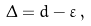<formula> <loc_0><loc_0><loc_500><loc_500>\Delta = d - \varepsilon \, ,</formula> 